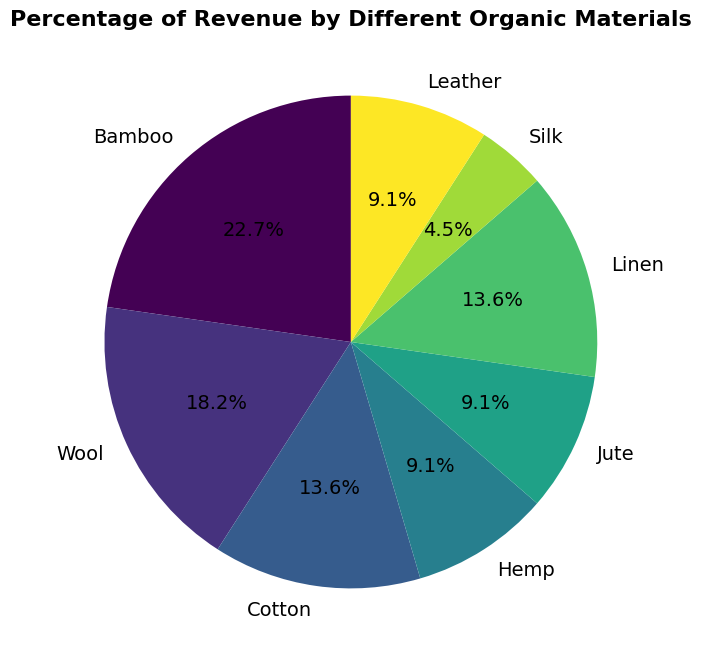What's the largest contributing material to the revenue? Look at the pie chart and identify the material with the largest percentage slice. Bamboo is 25%, which is the highest percentage.
Answer: Bamboo Which materials contribute equally to the revenue? Find materials with the same percentage values in the pie chart. Cotton and Linen both have 15%. Hemp, Jute, and Leather all have 10%.
Answer: Cotton and Linen, Hemp, Jute, and Leather How much more revenue does Bamboo generate compared to Silk? Bamboo contributes 25%, and Silk contributes 5%. Subtract Silk's percentage from Bamboo's percentage: 25% - 5% = 20%.
Answer: 20% What is the total percentage of revenue from Wool, Cotton, and Linen combined? Add the percentages of Wool (20%), Cotton (15%), and Linen (15%). 20% + 15% + 15% = 50%.
Answer: 50% Which material has the smallest contribution to the revenue? Look at the pie chart and identify the material with the smallest percentage slice. Silk contributes 5%, which is the smallest percentage.
Answer: Silk Is the revenue contribution from Leather greater or smaller than Hemp? Compare the percentages of Leather (10%) and Hemp (10%). Both are equal.
Answer: Equal What percentage of revenue is generated by materials with a contribution of 10% individually? Identify materials with a 10% contribution: Hemp, Jute, and Leather. There are three such materials, each contributing 10%.
Answer: 30% How does the visual representation differentiate between materials in the chart? The materials are differentiated by distinct colors and labeled with percentages on the pie chart.
Answer: Different colors and labels Which materials have revenue contributions greater than 10%? Identify materials with percentages greater than 10%. Bamboo (25%), Wool (20%), Cotton (15%), and Linen (15%) all contribute more than 10%.
Answer: Bamboo, Wool, Cotton, and Linen Is the combined revenue contribution of materials with 15% contribution the same as the material with the highest contribution? Sum the percentages of the materials contributing 15% each (Cotton and Linen). 15% + 15% = 30%, which is greater than Bamboo's 25%.
Answer: No 